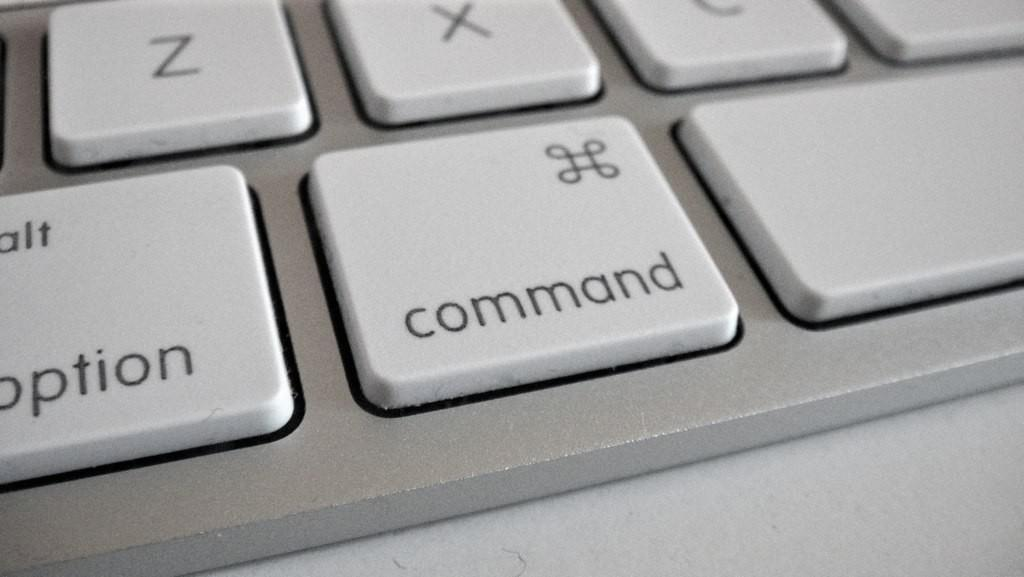Provide a one-sentence caption for the provided image. A white keyboard shows the command button next to the option button. 